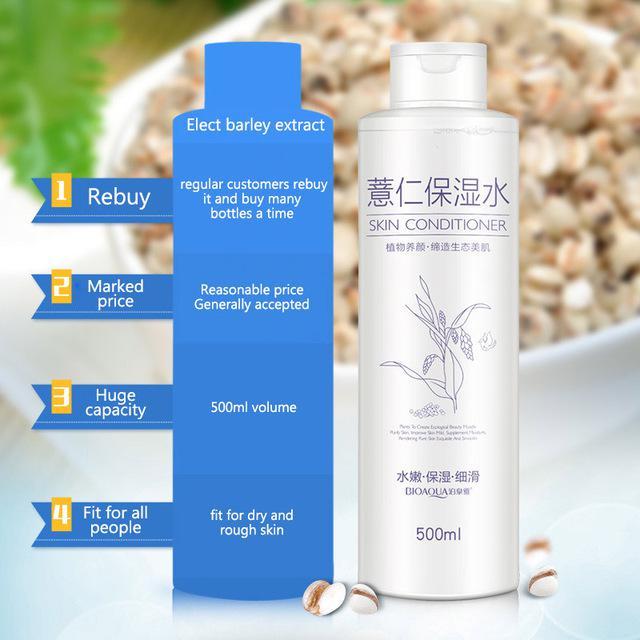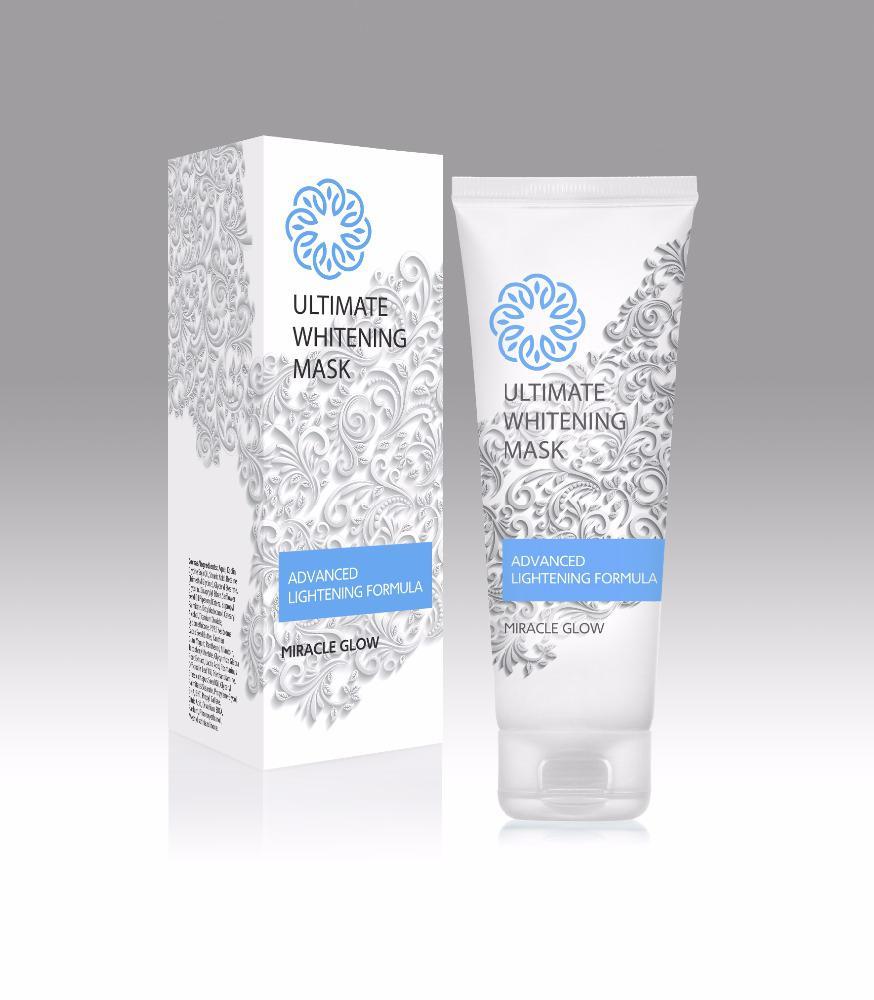The first image is the image on the left, the second image is the image on the right. For the images displayed, is the sentence "The left and right image contains the same number of  boxes and face cream bottles." factually correct? Answer yes or no. No. The first image is the image on the left, the second image is the image on the right. Analyze the images presented: Is the assertion "The right image shows a tube product standing on its cap to the right of its upright box." valid? Answer yes or no. Yes. 